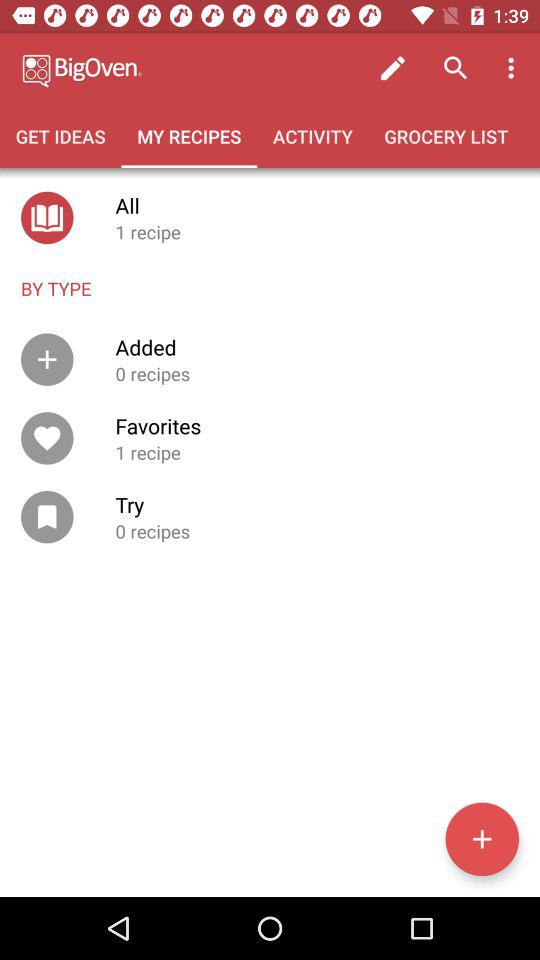What steps can I take to add a recipe to my 'Try' category? To add a recipe to your 'Try' category, you can start by tapping on the '+' sign within the app. This allows you to search for new recipes or enter one manually. Once you've found a recipe of interest, you can typically add it to the 'Try' section by selecting an option to 'save' or 'bookmark' the recipe, and choosing 'Try' as the designated category. 